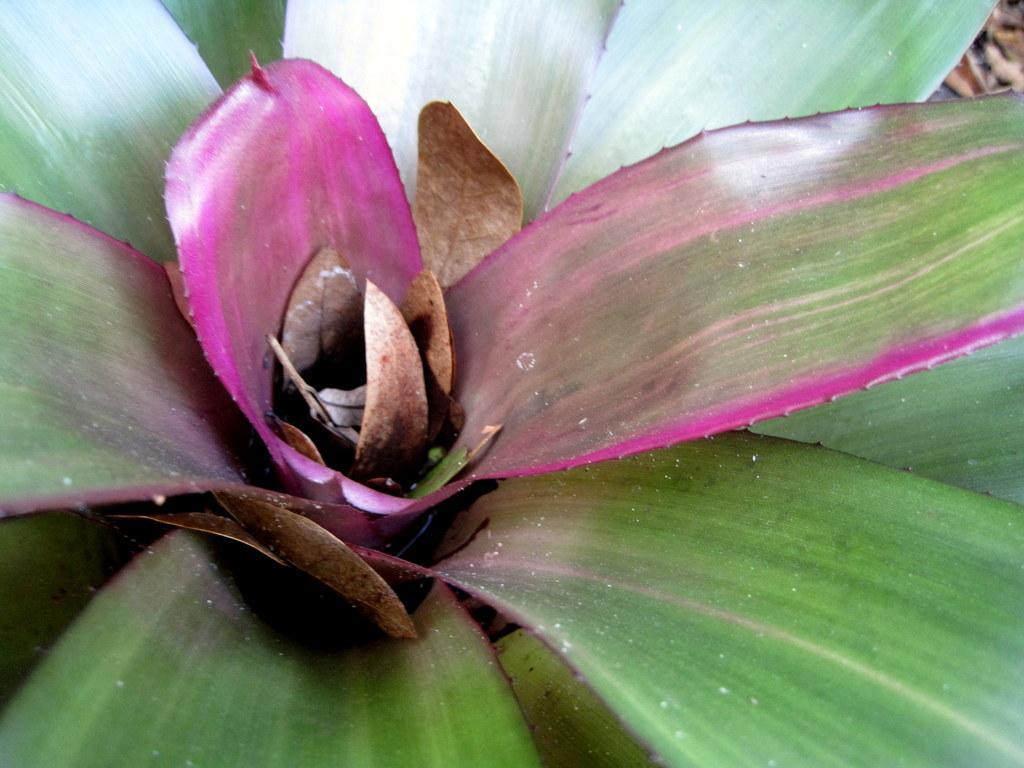Can you describe this image briefly? In this image we can see an aloe vera plant, and at the right corner of the image we there might be some leaves on the ground. 